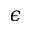Convert formula to latex. <formula><loc_0><loc_0><loc_500><loc_500>\epsilon</formula> 